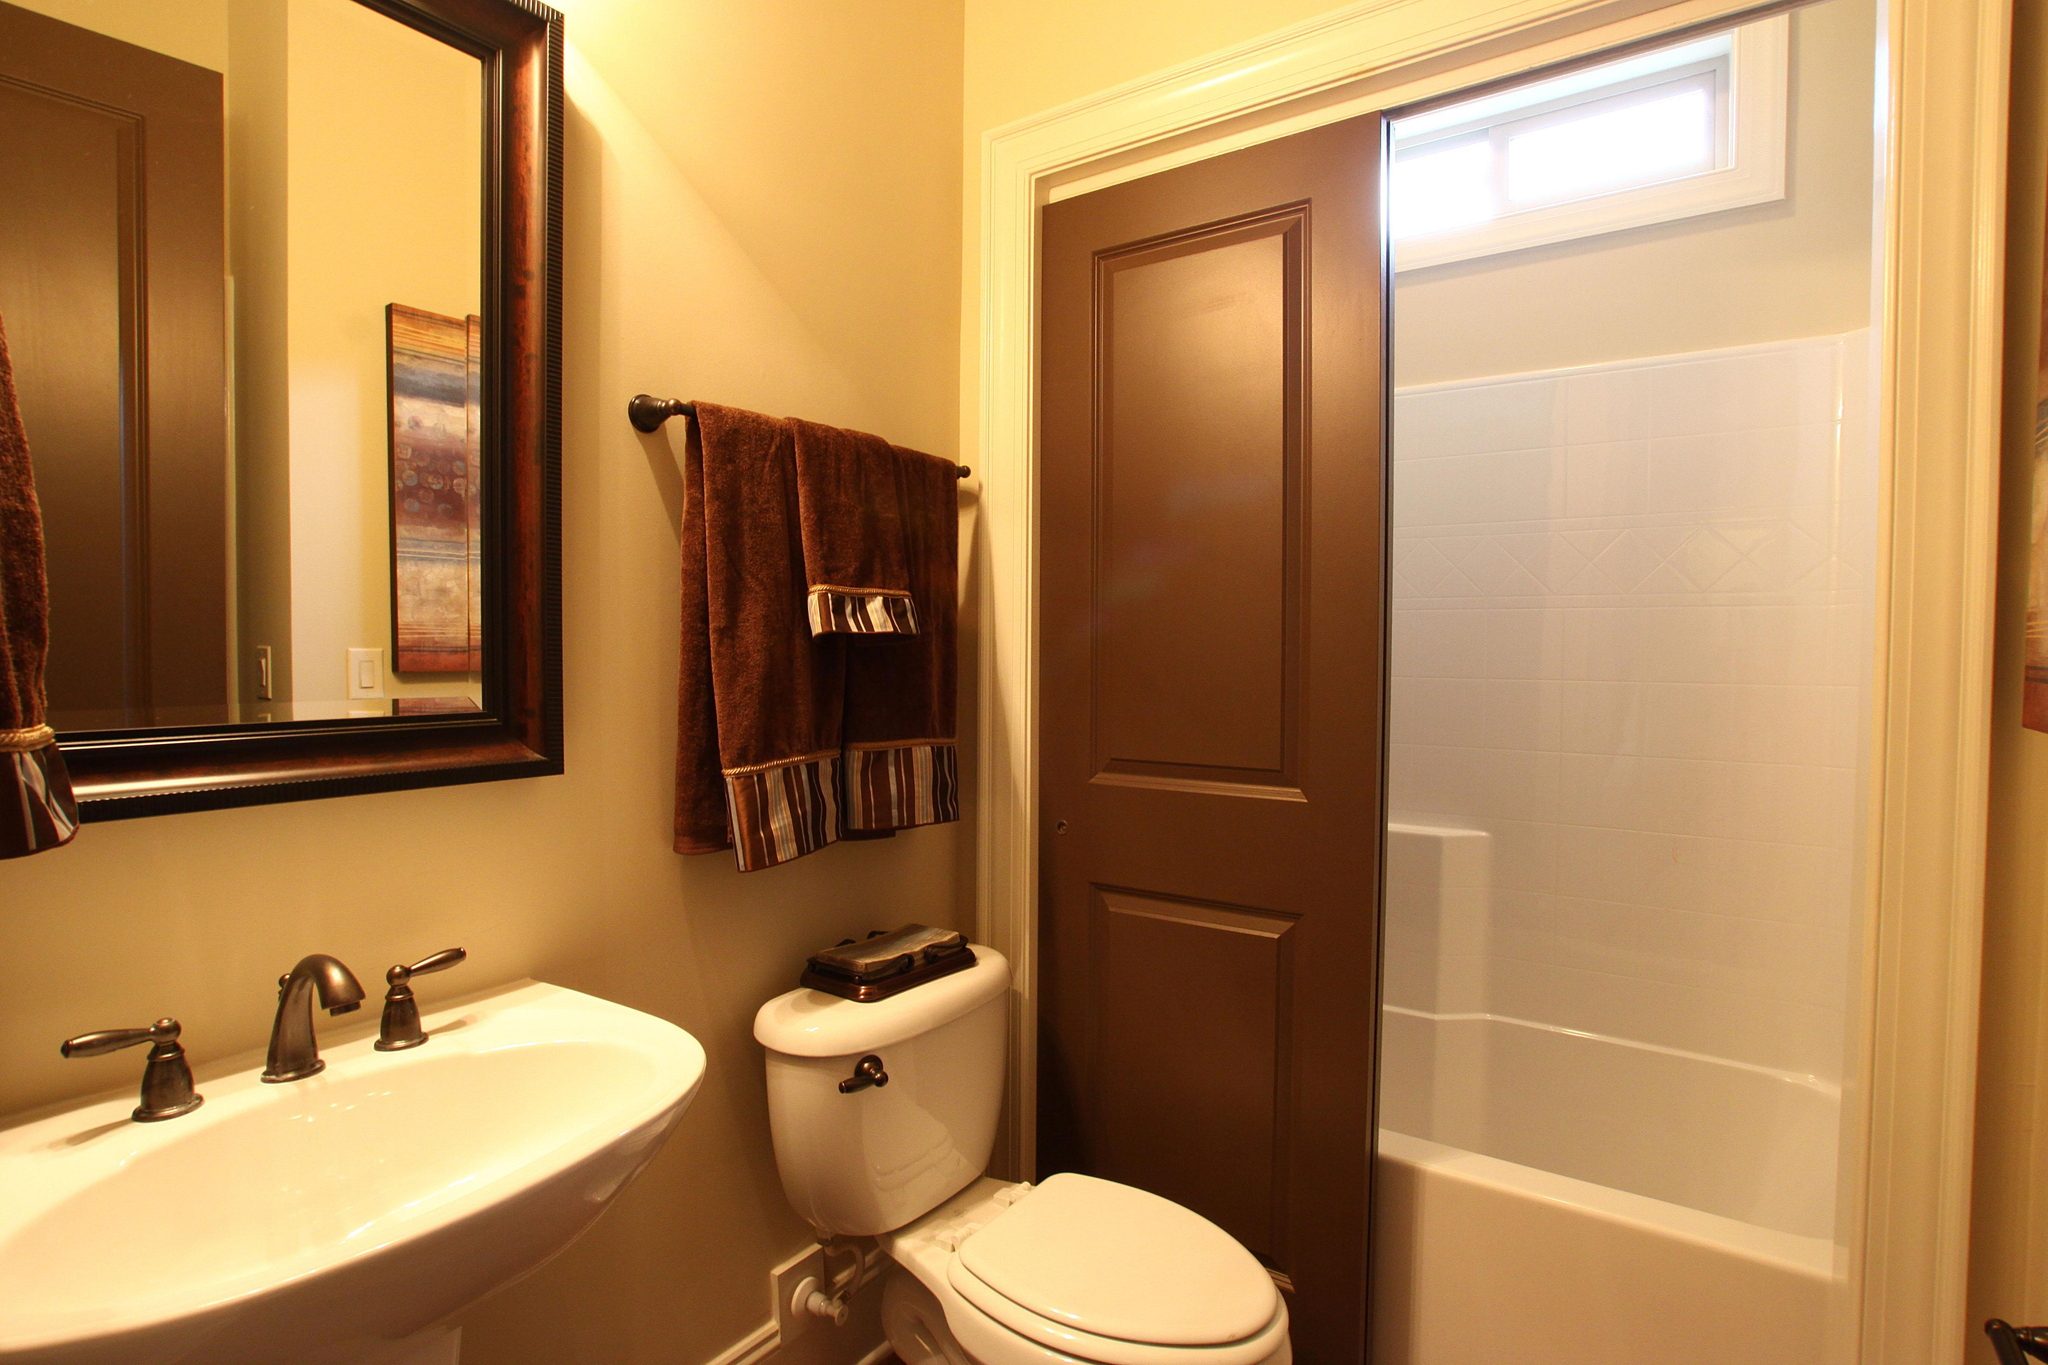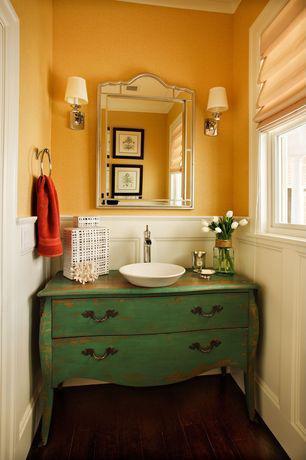The first image is the image on the left, the second image is the image on the right. Considering the images on both sides, is "Mirrors hang over a sink in each of the images." valid? Answer yes or no. Yes. The first image is the image on the left, the second image is the image on the right. Given the left and right images, does the statement "There are two sinks on top of cabinets." hold true? Answer yes or no. No. 